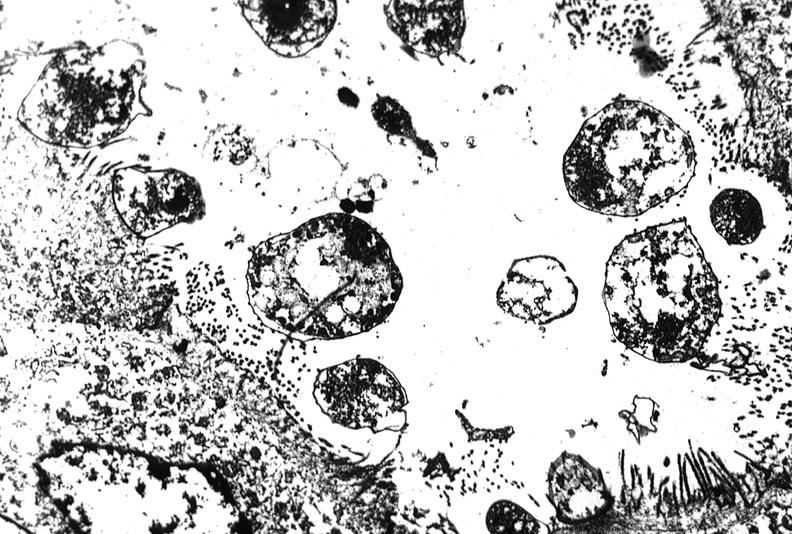what does this image show?
Answer the question using a single word or phrase. Colon biopsy 